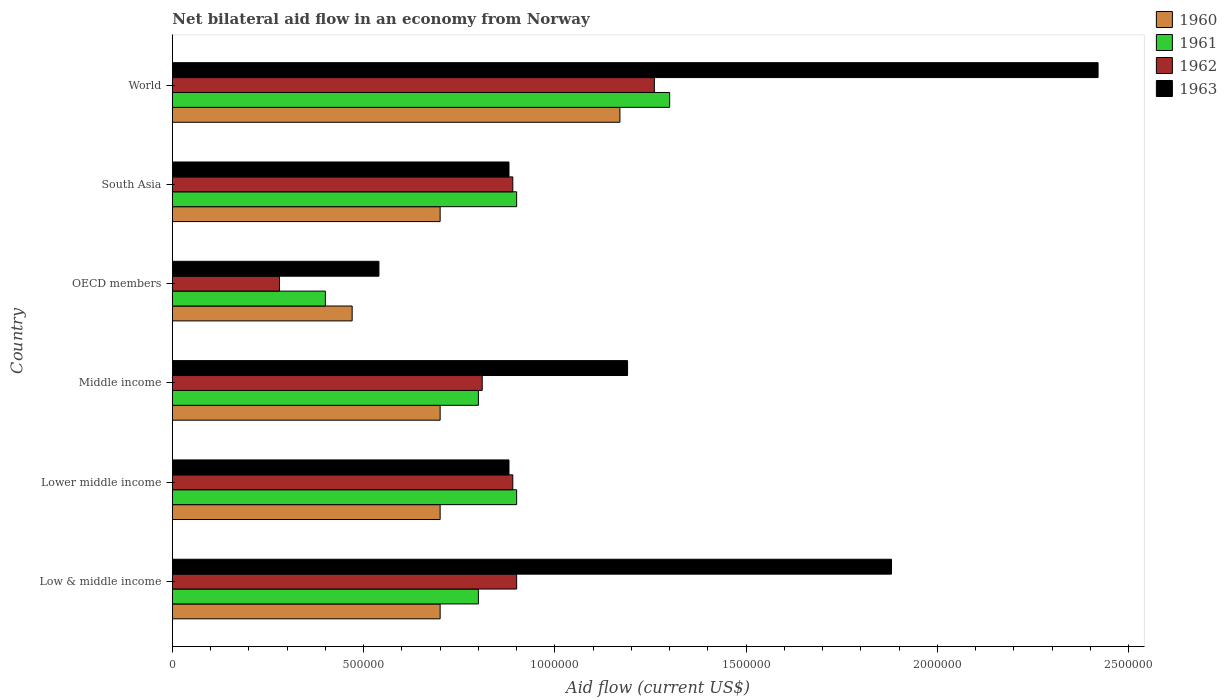How many groups of bars are there?
Give a very brief answer. 6. How many bars are there on the 3rd tick from the top?
Your response must be concise. 4. How many bars are there on the 6th tick from the bottom?
Your answer should be compact. 4. What is the label of the 4th group of bars from the top?
Give a very brief answer. Middle income. What is the net bilateral aid flow in 1963 in World?
Your response must be concise. 2.42e+06. Across all countries, what is the maximum net bilateral aid flow in 1963?
Provide a short and direct response. 2.42e+06. Across all countries, what is the minimum net bilateral aid flow in 1963?
Give a very brief answer. 5.40e+05. In which country was the net bilateral aid flow in 1962 minimum?
Offer a terse response. OECD members. What is the total net bilateral aid flow in 1961 in the graph?
Provide a succinct answer. 5.10e+06. What is the difference between the net bilateral aid flow in 1963 in Lower middle income and that in Middle income?
Ensure brevity in your answer.  -3.10e+05. What is the average net bilateral aid flow in 1962 per country?
Offer a very short reply. 8.38e+05. What is the difference between the net bilateral aid flow in 1962 and net bilateral aid flow in 1960 in World?
Make the answer very short. 9.00e+04. What is the ratio of the net bilateral aid flow in 1961 in OECD members to that in World?
Your response must be concise. 0.31. Is the net bilateral aid flow in 1960 in Low & middle income less than that in OECD members?
Keep it short and to the point. No. Is the difference between the net bilateral aid flow in 1962 in Low & middle income and Lower middle income greater than the difference between the net bilateral aid flow in 1960 in Low & middle income and Lower middle income?
Keep it short and to the point. Yes. What is the difference between the highest and the second highest net bilateral aid flow in 1962?
Make the answer very short. 3.60e+05. What is the difference between the highest and the lowest net bilateral aid flow in 1962?
Ensure brevity in your answer.  9.80e+05. In how many countries, is the net bilateral aid flow in 1963 greater than the average net bilateral aid flow in 1963 taken over all countries?
Make the answer very short. 2. Is the sum of the net bilateral aid flow in 1963 in Middle income and OECD members greater than the maximum net bilateral aid flow in 1961 across all countries?
Offer a terse response. Yes. Is it the case that in every country, the sum of the net bilateral aid flow in 1963 and net bilateral aid flow in 1962 is greater than the net bilateral aid flow in 1961?
Offer a terse response. Yes. How many bars are there?
Your answer should be very brief. 24. Are all the bars in the graph horizontal?
Make the answer very short. Yes. What is the difference between two consecutive major ticks on the X-axis?
Offer a very short reply. 5.00e+05. Does the graph contain grids?
Provide a succinct answer. No. How are the legend labels stacked?
Make the answer very short. Vertical. What is the title of the graph?
Keep it short and to the point. Net bilateral aid flow in an economy from Norway. Does "1971" appear as one of the legend labels in the graph?
Provide a short and direct response. No. What is the label or title of the X-axis?
Offer a very short reply. Aid flow (current US$). What is the label or title of the Y-axis?
Offer a very short reply. Country. What is the Aid flow (current US$) in 1960 in Low & middle income?
Your answer should be compact. 7.00e+05. What is the Aid flow (current US$) in 1961 in Low & middle income?
Your answer should be compact. 8.00e+05. What is the Aid flow (current US$) of 1962 in Low & middle income?
Offer a terse response. 9.00e+05. What is the Aid flow (current US$) of 1963 in Low & middle income?
Ensure brevity in your answer.  1.88e+06. What is the Aid flow (current US$) in 1960 in Lower middle income?
Offer a terse response. 7.00e+05. What is the Aid flow (current US$) in 1961 in Lower middle income?
Offer a terse response. 9.00e+05. What is the Aid flow (current US$) in 1962 in Lower middle income?
Your answer should be very brief. 8.90e+05. What is the Aid flow (current US$) in 1963 in Lower middle income?
Provide a succinct answer. 8.80e+05. What is the Aid flow (current US$) of 1962 in Middle income?
Offer a terse response. 8.10e+05. What is the Aid flow (current US$) in 1963 in Middle income?
Offer a very short reply. 1.19e+06. What is the Aid flow (current US$) in 1962 in OECD members?
Your answer should be compact. 2.80e+05. What is the Aid flow (current US$) of 1963 in OECD members?
Your response must be concise. 5.40e+05. What is the Aid flow (current US$) of 1960 in South Asia?
Provide a short and direct response. 7.00e+05. What is the Aid flow (current US$) in 1961 in South Asia?
Provide a short and direct response. 9.00e+05. What is the Aid flow (current US$) in 1962 in South Asia?
Provide a short and direct response. 8.90e+05. What is the Aid flow (current US$) of 1963 in South Asia?
Offer a very short reply. 8.80e+05. What is the Aid flow (current US$) in 1960 in World?
Ensure brevity in your answer.  1.17e+06. What is the Aid flow (current US$) in 1961 in World?
Ensure brevity in your answer.  1.30e+06. What is the Aid flow (current US$) in 1962 in World?
Provide a succinct answer. 1.26e+06. What is the Aid flow (current US$) in 1963 in World?
Give a very brief answer. 2.42e+06. Across all countries, what is the maximum Aid flow (current US$) of 1960?
Offer a terse response. 1.17e+06. Across all countries, what is the maximum Aid flow (current US$) in 1961?
Give a very brief answer. 1.30e+06. Across all countries, what is the maximum Aid flow (current US$) of 1962?
Offer a terse response. 1.26e+06. Across all countries, what is the maximum Aid flow (current US$) of 1963?
Make the answer very short. 2.42e+06. Across all countries, what is the minimum Aid flow (current US$) of 1961?
Provide a short and direct response. 4.00e+05. Across all countries, what is the minimum Aid flow (current US$) of 1962?
Provide a succinct answer. 2.80e+05. Across all countries, what is the minimum Aid flow (current US$) of 1963?
Your answer should be very brief. 5.40e+05. What is the total Aid flow (current US$) of 1960 in the graph?
Your answer should be very brief. 4.44e+06. What is the total Aid flow (current US$) of 1961 in the graph?
Your answer should be compact. 5.10e+06. What is the total Aid flow (current US$) in 1962 in the graph?
Provide a succinct answer. 5.03e+06. What is the total Aid flow (current US$) of 1963 in the graph?
Your answer should be compact. 7.79e+06. What is the difference between the Aid flow (current US$) in 1963 in Low & middle income and that in Lower middle income?
Ensure brevity in your answer.  1.00e+06. What is the difference between the Aid flow (current US$) in 1960 in Low & middle income and that in Middle income?
Provide a succinct answer. 0. What is the difference between the Aid flow (current US$) of 1961 in Low & middle income and that in Middle income?
Ensure brevity in your answer.  0. What is the difference between the Aid flow (current US$) of 1962 in Low & middle income and that in Middle income?
Provide a succinct answer. 9.00e+04. What is the difference between the Aid flow (current US$) of 1963 in Low & middle income and that in Middle income?
Offer a very short reply. 6.90e+05. What is the difference between the Aid flow (current US$) in 1960 in Low & middle income and that in OECD members?
Provide a succinct answer. 2.30e+05. What is the difference between the Aid flow (current US$) in 1961 in Low & middle income and that in OECD members?
Offer a very short reply. 4.00e+05. What is the difference between the Aid flow (current US$) of 1962 in Low & middle income and that in OECD members?
Provide a short and direct response. 6.20e+05. What is the difference between the Aid flow (current US$) in 1963 in Low & middle income and that in OECD members?
Provide a succinct answer. 1.34e+06. What is the difference between the Aid flow (current US$) in 1961 in Low & middle income and that in South Asia?
Make the answer very short. -1.00e+05. What is the difference between the Aid flow (current US$) in 1962 in Low & middle income and that in South Asia?
Make the answer very short. 10000. What is the difference between the Aid flow (current US$) in 1963 in Low & middle income and that in South Asia?
Give a very brief answer. 1.00e+06. What is the difference between the Aid flow (current US$) in 1960 in Low & middle income and that in World?
Keep it short and to the point. -4.70e+05. What is the difference between the Aid flow (current US$) of 1961 in Low & middle income and that in World?
Keep it short and to the point. -5.00e+05. What is the difference between the Aid flow (current US$) in 1962 in Low & middle income and that in World?
Provide a short and direct response. -3.60e+05. What is the difference between the Aid flow (current US$) in 1963 in Low & middle income and that in World?
Your answer should be very brief. -5.40e+05. What is the difference between the Aid flow (current US$) in 1963 in Lower middle income and that in Middle income?
Offer a terse response. -3.10e+05. What is the difference between the Aid flow (current US$) of 1961 in Lower middle income and that in OECD members?
Offer a very short reply. 5.00e+05. What is the difference between the Aid flow (current US$) of 1963 in Lower middle income and that in OECD members?
Ensure brevity in your answer.  3.40e+05. What is the difference between the Aid flow (current US$) in 1960 in Lower middle income and that in South Asia?
Ensure brevity in your answer.  0. What is the difference between the Aid flow (current US$) of 1963 in Lower middle income and that in South Asia?
Provide a succinct answer. 0. What is the difference between the Aid flow (current US$) of 1960 in Lower middle income and that in World?
Offer a terse response. -4.70e+05. What is the difference between the Aid flow (current US$) in 1961 in Lower middle income and that in World?
Ensure brevity in your answer.  -4.00e+05. What is the difference between the Aid flow (current US$) in 1962 in Lower middle income and that in World?
Your response must be concise. -3.70e+05. What is the difference between the Aid flow (current US$) of 1963 in Lower middle income and that in World?
Make the answer very short. -1.54e+06. What is the difference between the Aid flow (current US$) in 1961 in Middle income and that in OECD members?
Offer a very short reply. 4.00e+05. What is the difference between the Aid flow (current US$) in 1962 in Middle income and that in OECD members?
Provide a short and direct response. 5.30e+05. What is the difference between the Aid flow (current US$) of 1963 in Middle income and that in OECD members?
Your response must be concise. 6.50e+05. What is the difference between the Aid flow (current US$) in 1963 in Middle income and that in South Asia?
Offer a terse response. 3.10e+05. What is the difference between the Aid flow (current US$) of 1960 in Middle income and that in World?
Offer a terse response. -4.70e+05. What is the difference between the Aid flow (current US$) in 1961 in Middle income and that in World?
Give a very brief answer. -5.00e+05. What is the difference between the Aid flow (current US$) of 1962 in Middle income and that in World?
Offer a terse response. -4.50e+05. What is the difference between the Aid flow (current US$) in 1963 in Middle income and that in World?
Keep it short and to the point. -1.23e+06. What is the difference between the Aid flow (current US$) of 1961 in OECD members and that in South Asia?
Make the answer very short. -5.00e+05. What is the difference between the Aid flow (current US$) in 1962 in OECD members and that in South Asia?
Give a very brief answer. -6.10e+05. What is the difference between the Aid flow (current US$) of 1960 in OECD members and that in World?
Ensure brevity in your answer.  -7.00e+05. What is the difference between the Aid flow (current US$) of 1961 in OECD members and that in World?
Make the answer very short. -9.00e+05. What is the difference between the Aid flow (current US$) of 1962 in OECD members and that in World?
Your response must be concise. -9.80e+05. What is the difference between the Aid flow (current US$) of 1963 in OECD members and that in World?
Your answer should be compact. -1.88e+06. What is the difference between the Aid flow (current US$) in 1960 in South Asia and that in World?
Keep it short and to the point. -4.70e+05. What is the difference between the Aid flow (current US$) of 1961 in South Asia and that in World?
Offer a very short reply. -4.00e+05. What is the difference between the Aid flow (current US$) of 1962 in South Asia and that in World?
Give a very brief answer. -3.70e+05. What is the difference between the Aid flow (current US$) of 1963 in South Asia and that in World?
Make the answer very short. -1.54e+06. What is the difference between the Aid flow (current US$) in 1960 in Low & middle income and the Aid flow (current US$) in 1961 in Lower middle income?
Your answer should be very brief. -2.00e+05. What is the difference between the Aid flow (current US$) in 1960 in Low & middle income and the Aid flow (current US$) in 1962 in Lower middle income?
Ensure brevity in your answer.  -1.90e+05. What is the difference between the Aid flow (current US$) of 1960 in Low & middle income and the Aid flow (current US$) of 1963 in Lower middle income?
Your response must be concise. -1.80e+05. What is the difference between the Aid flow (current US$) in 1961 in Low & middle income and the Aid flow (current US$) in 1963 in Lower middle income?
Keep it short and to the point. -8.00e+04. What is the difference between the Aid flow (current US$) in 1960 in Low & middle income and the Aid flow (current US$) in 1961 in Middle income?
Your response must be concise. -1.00e+05. What is the difference between the Aid flow (current US$) of 1960 in Low & middle income and the Aid flow (current US$) of 1962 in Middle income?
Your response must be concise. -1.10e+05. What is the difference between the Aid flow (current US$) of 1960 in Low & middle income and the Aid flow (current US$) of 1963 in Middle income?
Offer a very short reply. -4.90e+05. What is the difference between the Aid flow (current US$) of 1961 in Low & middle income and the Aid flow (current US$) of 1963 in Middle income?
Offer a terse response. -3.90e+05. What is the difference between the Aid flow (current US$) in 1962 in Low & middle income and the Aid flow (current US$) in 1963 in Middle income?
Offer a very short reply. -2.90e+05. What is the difference between the Aid flow (current US$) of 1960 in Low & middle income and the Aid flow (current US$) of 1962 in OECD members?
Provide a succinct answer. 4.20e+05. What is the difference between the Aid flow (current US$) in 1961 in Low & middle income and the Aid flow (current US$) in 1962 in OECD members?
Your response must be concise. 5.20e+05. What is the difference between the Aid flow (current US$) of 1962 in Low & middle income and the Aid flow (current US$) of 1963 in OECD members?
Your response must be concise. 3.60e+05. What is the difference between the Aid flow (current US$) of 1960 in Low & middle income and the Aid flow (current US$) of 1961 in South Asia?
Offer a very short reply. -2.00e+05. What is the difference between the Aid flow (current US$) of 1962 in Low & middle income and the Aid flow (current US$) of 1963 in South Asia?
Offer a very short reply. 2.00e+04. What is the difference between the Aid flow (current US$) in 1960 in Low & middle income and the Aid flow (current US$) in 1961 in World?
Your response must be concise. -6.00e+05. What is the difference between the Aid flow (current US$) in 1960 in Low & middle income and the Aid flow (current US$) in 1962 in World?
Provide a succinct answer. -5.60e+05. What is the difference between the Aid flow (current US$) in 1960 in Low & middle income and the Aid flow (current US$) in 1963 in World?
Your response must be concise. -1.72e+06. What is the difference between the Aid flow (current US$) in 1961 in Low & middle income and the Aid flow (current US$) in 1962 in World?
Provide a succinct answer. -4.60e+05. What is the difference between the Aid flow (current US$) in 1961 in Low & middle income and the Aid flow (current US$) in 1963 in World?
Your answer should be compact. -1.62e+06. What is the difference between the Aid flow (current US$) of 1962 in Low & middle income and the Aid flow (current US$) of 1963 in World?
Keep it short and to the point. -1.52e+06. What is the difference between the Aid flow (current US$) of 1960 in Lower middle income and the Aid flow (current US$) of 1961 in Middle income?
Give a very brief answer. -1.00e+05. What is the difference between the Aid flow (current US$) of 1960 in Lower middle income and the Aid flow (current US$) of 1963 in Middle income?
Offer a very short reply. -4.90e+05. What is the difference between the Aid flow (current US$) in 1961 in Lower middle income and the Aid flow (current US$) in 1962 in Middle income?
Keep it short and to the point. 9.00e+04. What is the difference between the Aid flow (current US$) in 1961 in Lower middle income and the Aid flow (current US$) in 1963 in Middle income?
Your answer should be compact. -2.90e+05. What is the difference between the Aid flow (current US$) in 1960 in Lower middle income and the Aid flow (current US$) in 1962 in OECD members?
Ensure brevity in your answer.  4.20e+05. What is the difference between the Aid flow (current US$) in 1961 in Lower middle income and the Aid flow (current US$) in 1962 in OECD members?
Your response must be concise. 6.20e+05. What is the difference between the Aid flow (current US$) of 1961 in Lower middle income and the Aid flow (current US$) of 1963 in OECD members?
Provide a succinct answer. 3.60e+05. What is the difference between the Aid flow (current US$) of 1962 in Lower middle income and the Aid flow (current US$) of 1963 in OECD members?
Give a very brief answer. 3.50e+05. What is the difference between the Aid flow (current US$) in 1960 in Lower middle income and the Aid flow (current US$) in 1963 in South Asia?
Keep it short and to the point. -1.80e+05. What is the difference between the Aid flow (current US$) of 1961 in Lower middle income and the Aid flow (current US$) of 1962 in South Asia?
Offer a very short reply. 10000. What is the difference between the Aid flow (current US$) of 1961 in Lower middle income and the Aid flow (current US$) of 1963 in South Asia?
Keep it short and to the point. 2.00e+04. What is the difference between the Aid flow (current US$) in 1962 in Lower middle income and the Aid flow (current US$) in 1963 in South Asia?
Your response must be concise. 10000. What is the difference between the Aid flow (current US$) in 1960 in Lower middle income and the Aid flow (current US$) in 1961 in World?
Provide a succinct answer. -6.00e+05. What is the difference between the Aid flow (current US$) in 1960 in Lower middle income and the Aid flow (current US$) in 1962 in World?
Keep it short and to the point. -5.60e+05. What is the difference between the Aid flow (current US$) of 1960 in Lower middle income and the Aid flow (current US$) of 1963 in World?
Keep it short and to the point. -1.72e+06. What is the difference between the Aid flow (current US$) of 1961 in Lower middle income and the Aid flow (current US$) of 1962 in World?
Your answer should be very brief. -3.60e+05. What is the difference between the Aid flow (current US$) in 1961 in Lower middle income and the Aid flow (current US$) in 1963 in World?
Keep it short and to the point. -1.52e+06. What is the difference between the Aid flow (current US$) in 1962 in Lower middle income and the Aid flow (current US$) in 1963 in World?
Your response must be concise. -1.53e+06. What is the difference between the Aid flow (current US$) of 1960 in Middle income and the Aid flow (current US$) of 1961 in OECD members?
Ensure brevity in your answer.  3.00e+05. What is the difference between the Aid flow (current US$) of 1960 in Middle income and the Aid flow (current US$) of 1962 in OECD members?
Offer a very short reply. 4.20e+05. What is the difference between the Aid flow (current US$) in 1961 in Middle income and the Aid flow (current US$) in 1962 in OECD members?
Make the answer very short. 5.20e+05. What is the difference between the Aid flow (current US$) in 1962 in Middle income and the Aid flow (current US$) in 1963 in OECD members?
Make the answer very short. 2.70e+05. What is the difference between the Aid flow (current US$) in 1960 in Middle income and the Aid flow (current US$) in 1961 in South Asia?
Provide a short and direct response. -2.00e+05. What is the difference between the Aid flow (current US$) in 1961 in Middle income and the Aid flow (current US$) in 1962 in South Asia?
Provide a succinct answer. -9.00e+04. What is the difference between the Aid flow (current US$) in 1961 in Middle income and the Aid flow (current US$) in 1963 in South Asia?
Give a very brief answer. -8.00e+04. What is the difference between the Aid flow (current US$) in 1962 in Middle income and the Aid flow (current US$) in 1963 in South Asia?
Make the answer very short. -7.00e+04. What is the difference between the Aid flow (current US$) in 1960 in Middle income and the Aid flow (current US$) in 1961 in World?
Offer a terse response. -6.00e+05. What is the difference between the Aid flow (current US$) in 1960 in Middle income and the Aid flow (current US$) in 1962 in World?
Offer a terse response. -5.60e+05. What is the difference between the Aid flow (current US$) in 1960 in Middle income and the Aid flow (current US$) in 1963 in World?
Make the answer very short. -1.72e+06. What is the difference between the Aid flow (current US$) in 1961 in Middle income and the Aid flow (current US$) in 1962 in World?
Provide a succinct answer. -4.60e+05. What is the difference between the Aid flow (current US$) of 1961 in Middle income and the Aid flow (current US$) of 1963 in World?
Your answer should be very brief. -1.62e+06. What is the difference between the Aid flow (current US$) in 1962 in Middle income and the Aid flow (current US$) in 1963 in World?
Your answer should be very brief. -1.61e+06. What is the difference between the Aid flow (current US$) of 1960 in OECD members and the Aid flow (current US$) of 1961 in South Asia?
Make the answer very short. -4.30e+05. What is the difference between the Aid flow (current US$) in 1960 in OECD members and the Aid flow (current US$) in 1962 in South Asia?
Make the answer very short. -4.20e+05. What is the difference between the Aid flow (current US$) in 1960 in OECD members and the Aid flow (current US$) in 1963 in South Asia?
Your response must be concise. -4.10e+05. What is the difference between the Aid flow (current US$) in 1961 in OECD members and the Aid flow (current US$) in 1962 in South Asia?
Give a very brief answer. -4.90e+05. What is the difference between the Aid flow (current US$) in 1961 in OECD members and the Aid flow (current US$) in 1963 in South Asia?
Offer a terse response. -4.80e+05. What is the difference between the Aid flow (current US$) of 1962 in OECD members and the Aid flow (current US$) of 1963 in South Asia?
Provide a short and direct response. -6.00e+05. What is the difference between the Aid flow (current US$) of 1960 in OECD members and the Aid flow (current US$) of 1961 in World?
Your response must be concise. -8.30e+05. What is the difference between the Aid flow (current US$) of 1960 in OECD members and the Aid flow (current US$) of 1962 in World?
Make the answer very short. -7.90e+05. What is the difference between the Aid flow (current US$) of 1960 in OECD members and the Aid flow (current US$) of 1963 in World?
Your answer should be very brief. -1.95e+06. What is the difference between the Aid flow (current US$) in 1961 in OECD members and the Aid flow (current US$) in 1962 in World?
Provide a short and direct response. -8.60e+05. What is the difference between the Aid flow (current US$) of 1961 in OECD members and the Aid flow (current US$) of 1963 in World?
Your answer should be very brief. -2.02e+06. What is the difference between the Aid flow (current US$) of 1962 in OECD members and the Aid flow (current US$) of 1963 in World?
Keep it short and to the point. -2.14e+06. What is the difference between the Aid flow (current US$) of 1960 in South Asia and the Aid flow (current US$) of 1961 in World?
Offer a terse response. -6.00e+05. What is the difference between the Aid flow (current US$) of 1960 in South Asia and the Aid flow (current US$) of 1962 in World?
Your answer should be very brief. -5.60e+05. What is the difference between the Aid flow (current US$) in 1960 in South Asia and the Aid flow (current US$) in 1963 in World?
Your answer should be compact. -1.72e+06. What is the difference between the Aid flow (current US$) in 1961 in South Asia and the Aid flow (current US$) in 1962 in World?
Ensure brevity in your answer.  -3.60e+05. What is the difference between the Aid flow (current US$) of 1961 in South Asia and the Aid flow (current US$) of 1963 in World?
Your answer should be compact. -1.52e+06. What is the difference between the Aid flow (current US$) of 1962 in South Asia and the Aid flow (current US$) of 1963 in World?
Offer a very short reply. -1.53e+06. What is the average Aid flow (current US$) in 1960 per country?
Make the answer very short. 7.40e+05. What is the average Aid flow (current US$) in 1961 per country?
Offer a terse response. 8.50e+05. What is the average Aid flow (current US$) in 1962 per country?
Keep it short and to the point. 8.38e+05. What is the average Aid flow (current US$) in 1963 per country?
Provide a short and direct response. 1.30e+06. What is the difference between the Aid flow (current US$) in 1960 and Aid flow (current US$) in 1961 in Low & middle income?
Ensure brevity in your answer.  -1.00e+05. What is the difference between the Aid flow (current US$) of 1960 and Aid flow (current US$) of 1963 in Low & middle income?
Offer a very short reply. -1.18e+06. What is the difference between the Aid flow (current US$) of 1961 and Aid flow (current US$) of 1963 in Low & middle income?
Your answer should be very brief. -1.08e+06. What is the difference between the Aid flow (current US$) in 1962 and Aid flow (current US$) in 1963 in Low & middle income?
Give a very brief answer. -9.80e+05. What is the difference between the Aid flow (current US$) of 1960 and Aid flow (current US$) of 1963 in Lower middle income?
Ensure brevity in your answer.  -1.80e+05. What is the difference between the Aid flow (current US$) of 1961 and Aid flow (current US$) of 1963 in Lower middle income?
Offer a very short reply. 2.00e+04. What is the difference between the Aid flow (current US$) in 1960 and Aid flow (current US$) in 1961 in Middle income?
Give a very brief answer. -1.00e+05. What is the difference between the Aid flow (current US$) of 1960 and Aid flow (current US$) of 1963 in Middle income?
Offer a very short reply. -4.90e+05. What is the difference between the Aid flow (current US$) in 1961 and Aid flow (current US$) in 1963 in Middle income?
Ensure brevity in your answer.  -3.90e+05. What is the difference between the Aid flow (current US$) in 1962 and Aid flow (current US$) in 1963 in Middle income?
Keep it short and to the point. -3.80e+05. What is the difference between the Aid flow (current US$) of 1960 and Aid flow (current US$) of 1962 in OECD members?
Ensure brevity in your answer.  1.90e+05. What is the difference between the Aid flow (current US$) in 1961 and Aid flow (current US$) in 1962 in OECD members?
Your answer should be very brief. 1.20e+05. What is the difference between the Aid flow (current US$) in 1961 and Aid flow (current US$) in 1963 in OECD members?
Give a very brief answer. -1.40e+05. What is the difference between the Aid flow (current US$) of 1960 and Aid flow (current US$) of 1963 in South Asia?
Ensure brevity in your answer.  -1.80e+05. What is the difference between the Aid flow (current US$) of 1960 and Aid flow (current US$) of 1962 in World?
Give a very brief answer. -9.00e+04. What is the difference between the Aid flow (current US$) in 1960 and Aid flow (current US$) in 1963 in World?
Ensure brevity in your answer.  -1.25e+06. What is the difference between the Aid flow (current US$) in 1961 and Aid flow (current US$) in 1962 in World?
Make the answer very short. 4.00e+04. What is the difference between the Aid flow (current US$) of 1961 and Aid flow (current US$) of 1963 in World?
Offer a terse response. -1.12e+06. What is the difference between the Aid flow (current US$) in 1962 and Aid flow (current US$) in 1963 in World?
Your answer should be very brief. -1.16e+06. What is the ratio of the Aid flow (current US$) in 1960 in Low & middle income to that in Lower middle income?
Your answer should be compact. 1. What is the ratio of the Aid flow (current US$) of 1962 in Low & middle income to that in Lower middle income?
Provide a succinct answer. 1.01. What is the ratio of the Aid flow (current US$) in 1963 in Low & middle income to that in Lower middle income?
Make the answer very short. 2.14. What is the ratio of the Aid flow (current US$) of 1963 in Low & middle income to that in Middle income?
Offer a very short reply. 1.58. What is the ratio of the Aid flow (current US$) in 1960 in Low & middle income to that in OECD members?
Offer a terse response. 1.49. What is the ratio of the Aid flow (current US$) in 1962 in Low & middle income to that in OECD members?
Your response must be concise. 3.21. What is the ratio of the Aid flow (current US$) of 1963 in Low & middle income to that in OECD members?
Keep it short and to the point. 3.48. What is the ratio of the Aid flow (current US$) in 1961 in Low & middle income to that in South Asia?
Your answer should be compact. 0.89. What is the ratio of the Aid flow (current US$) of 1962 in Low & middle income to that in South Asia?
Give a very brief answer. 1.01. What is the ratio of the Aid flow (current US$) in 1963 in Low & middle income to that in South Asia?
Your response must be concise. 2.14. What is the ratio of the Aid flow (current US$) of 1960 in Low & middle income to that in World?
Ensure brevity in your answer.  0.6. What is the ratio of the Aid flow (current US$) in 1961 in Low & middle income to that in World?
Make the answer very short. 0.62. What is the ratio of the Aid flow (current US$) of 1962 in Low & middle income to that in World?
Provide a succinct answer. 0.71. What is the ratio of the Aid flow (current US$) of 1963 in Low & middle income to that in World?
Your answer should be very brief. 0.78. What is the ratio of the Aid flow (current US$) of 1961 in Lower middle income to that in Middle income?
Offer a terse response. 1.12. What is the ratio of the Aid flow (current US$) of 1962 in Lower middle income to that in Middle income?
Ensure brevity in your answer.  1.1. What is the ratio of the Aid flow (current US$) of 1963 in Lower middle income to that in Middle income?
Your answer should be very brief. 0.74. What is the ratio of the Aid flow (current US$) in 1960 in Lower middle income to that in OECD members?
Offer a very short reply. 1.49. What is the ratio of the Aid flow (current US$) of 1961 in Lower middle income to that in OECD members?
Provide a succinct answer. 2.25. What is the ratio of the Aid flow (current US$) in 1962 in Lower middle income to that in OECD members?
Ensure brevity in your answer.  3.18. What is the ratio of the Aid flow (current US$) in 1963 in Lower middle income to that in OECD members?
Your response must be concise. 1.63. What is the ratio of the Aid flow (current US$) in 1961 in Lower middle income to that in South Asia?
Your answer should be very brief. 1. What is the ratio of the Aid flow (current US$) in 1962 in Lower middle income to that in South Asia?
Ensure brevity in your answer.  1. What is the ratio of the Aid flow (current US$) of 1960 in Lower middle income to that in World?
Provide a short and direct response. 0.6. What is the ratio of the Aid flow (current US$) of 1961 in Lower middle income to that in World?
Provide a succinct answer. 0.69. What is the ratio of the Aid flow (current US$) of 1962 in Lower middle income to that in World?
Provide a short and direct response. 0.71. What is the ratio of the Aid flow (current US$) of 1963 in Lower middle income to that in World?
Your answer should be compact. 0.36. What is the ratio of the Aid flow (current US$) of 1960 in Middle income to that in OECD members?
Offer a very short reply. 1.49. What is the ratio of the Aid flow (current US$) of 1961 in Middle income to that in OECD members?
Provide a succinct answer. 2. What is the ratio of the Aid flow (current US$) of 1962 in Middle income to that in OECD members?
Ensure brevity in your answer.  2.89. What is the ratio of the Aid flow (current US$) of 1963 in Middle income to that in OECD members?
Your answer should be compact. 2.2. What is the ratio of the Aid flow (current US$) of 1960 in Middle income to that in South Asia?
Offer a terse response. 1. What is the ratio of the Aid flow (current US$) of 1961 in Middle income to that in South Asia?
Keep it short and to the point. 0.89. What is the ratio of the Aid flow (current US$) of 1962 in Middle income to that in South Asia?
Provide a succinct answer. 0.91. What is the ratio of the Aid flow (current US$) in 1963 in Middle income to that in South Asia?
Keep it short and to the point. 1.35. What is the ratio of the Aid flow (current US$) of 1960 in Middle income to that in World?
Provide a short and direct response. 0.6. What is the ratio of the Aid flow (current US$) of 1961 in Middle income to that in World?
Offer a very short reply. 0.62. What is the ratio of the Aid flow (current US$) of 1962 in Middle income to that in World?
Your answer should be very brief. 0.64. What is the ratio of the Aid flow (current US$) of 1963 in Middle income to that in World?
Provide a short and direct response. 0.49. What is the ratio of the Aid flow (current US$) in 1960 in OECD members to that in South Asia?
Make the answer very short. 0.67. What is the ratio of the Aid flow (current US$) in 1961 in OECD members to that in South Asia?
Keep it short and to the point. 0.44. What is the ratio of the Aid flow (current US$) of 1962 in OECD members to that in South Asia?
Provide a short and direct response. 0.31. What is the ratio of the Aid flow (current US$) of 1963 in OECD members to that in South Asia?
Give a very brief answer. 0.61. What is the ratio of the Aid flow (current US$) of 1960 in OECD members to that in World?
Offer a terse response. 0.4. What is the ratio of the Aid flow (current US$) in 1961 in OECD members to that in World?
Offer a terse response. 0.31. What is the ratio of the Aid flow (current US$) of 1962 in OECD members to that in World?
Your answer should be very brief. 0.22. What is the ratio of the Aid flow (current US$) in 1963 in OECD members to that in World?
Provide a short and direct response. 0.22. What is the ratio of the Aid flow (current US$) in 1960 in South Asia to that in World?
Offer a very short reply. 0.6. What is the ratio of the Aid flow (current US$) of 1961 in South Asia to that in World?
Provide a short and direct response. 0.69. What is the ratio of the Aid flow (current US$) in 1962 in South Asia to that in World?
Make the answer very short. 0.71. What is the ratio of the Aid flow (current US$) of 1963 in South Asia to that in World?
Make the answer very short. 0.36. What is the difference between the highest and the second highest Aid flow (current US$) of 1960?
Your answer should be compact. 4.70e+05. What is the difference between the highest and the second highest Aid flow (current US$) in 1961?
Offer a terse response. 4.00e+05. What is the difference between the highest and the second highest Aid flow (current US$) in 1963?
Ensure brevity in your answer.  5.40e+05. What is the difference between the highest and the lowest Aid flow (current US$) in 1960?
Your response must be concise. 7.00e+05. What is the difference between the highest and the lowest Aid flow (current US$) in 1962?
Your answer should be compact. 9.80e+05. What is the difference between the highest and the lowest Aid flow (current US$) in 1963?
Your answer should be compact. 1.88e+06. 